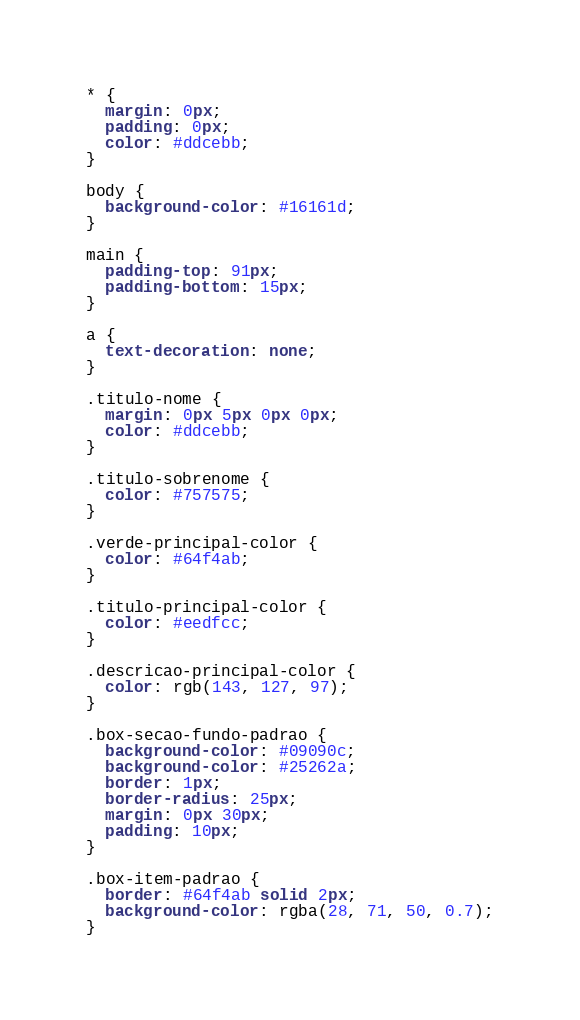Convert code to text. <code><loc_0><loc_0><loc_500><loc_500><_CSS_>* {
  margin: 0px;
  padding: 0px;
  color: #ddcebb;
}

body {
  background-color: #16161d;
}

main {
  padding-top: 91px;
  padding-bottom: 15px;
}

a {
  text-decoration: none;
}

.titulo-nome {
  margin: 0px 5px 0px 0px;
  color: #ddcebb;
}

.titulo-sobrenome {
  color: #757575;
}

.verde-principal-color {
  color: #64f4ab;
}

.titulo-principal-color {
  color: #eedfcc;
}

.descricao-principal-color {
  color: rgb(143, 127, 97);
}

.box-secao-fundo-padrao {
  background-color: #09090c;
  background-color: #25262a;
  border: 1px;
  border-radius: 25px;
  margin: 0px 30px;
  padding: 10px;
}

.box-item-padrao {
  border: #64f4ab solid 2px;
  background-color: rgba(28, 71, 50, 0.7);
}
</code> 